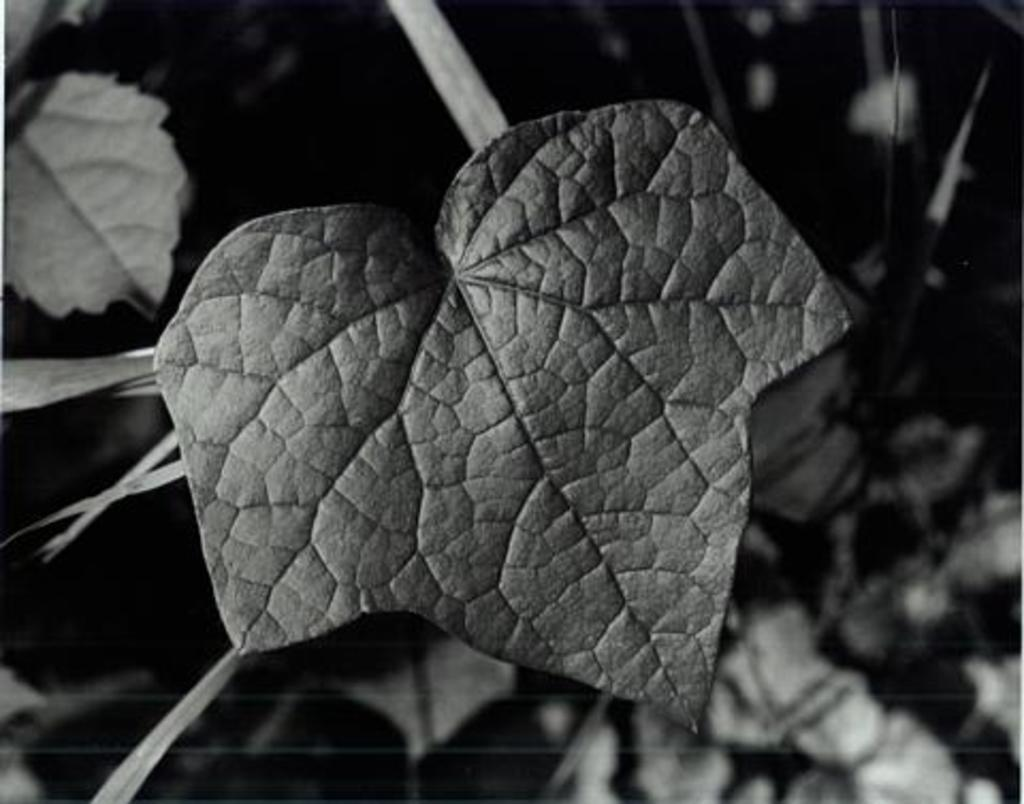What is located in the foreground of the image? There is a leaf in the foreground of the image. What can be seen in the background of the image? There are leaves visible in the background of the image. What is the color scheme of the image? The image is in black and white. What is the purpose of the science experiment being conducted in the image? There is no science experiment present in the image; it features a leaf in the foreground and background. What type of frame is used to display the image? The facts provided do not mention any frame or display method for the image. 